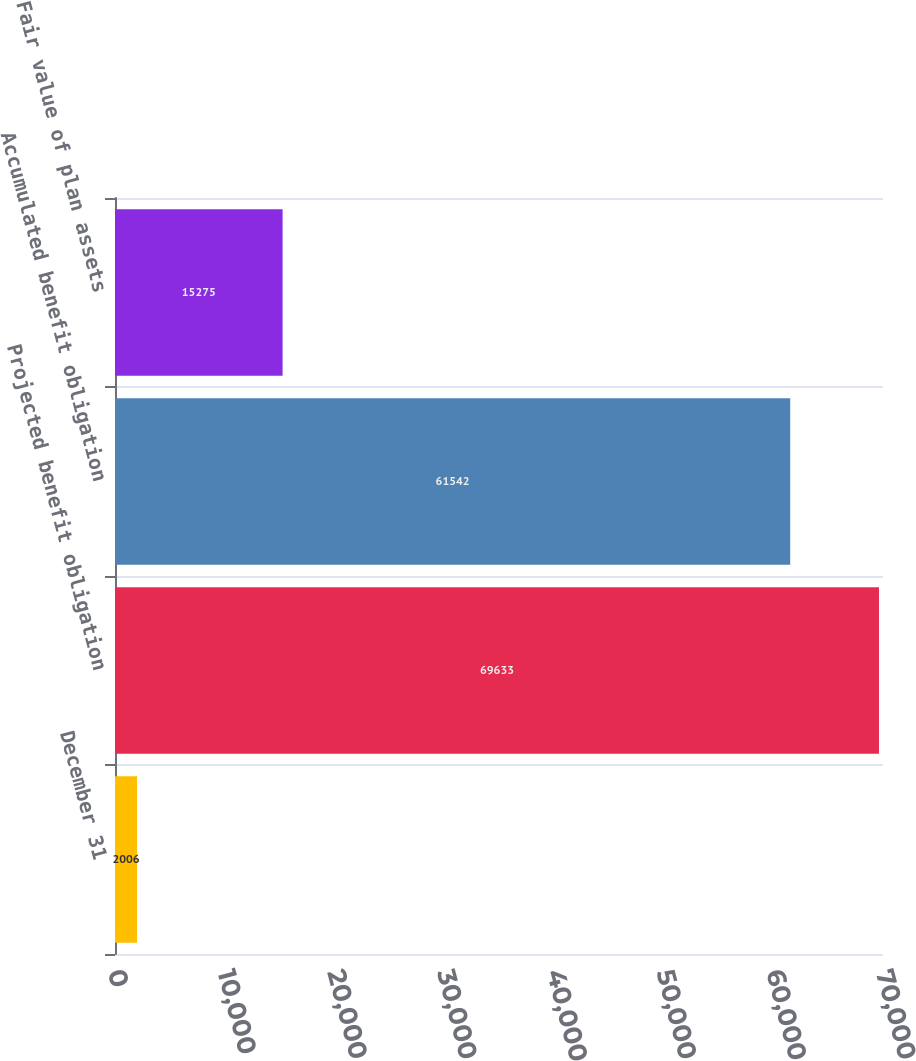Convert chart to OTSL. <chart><loc_0><loc_0><loc_500><loc_500><bar_chart><fcel>December 31<fcel>Projected benefit obligation<fcel>Accumulated benefit obligation<fcel>Fair value of plan assets<nl><fcel>2006<fcel>69633<fcel>61542<fcel>15275<nl></chart> 